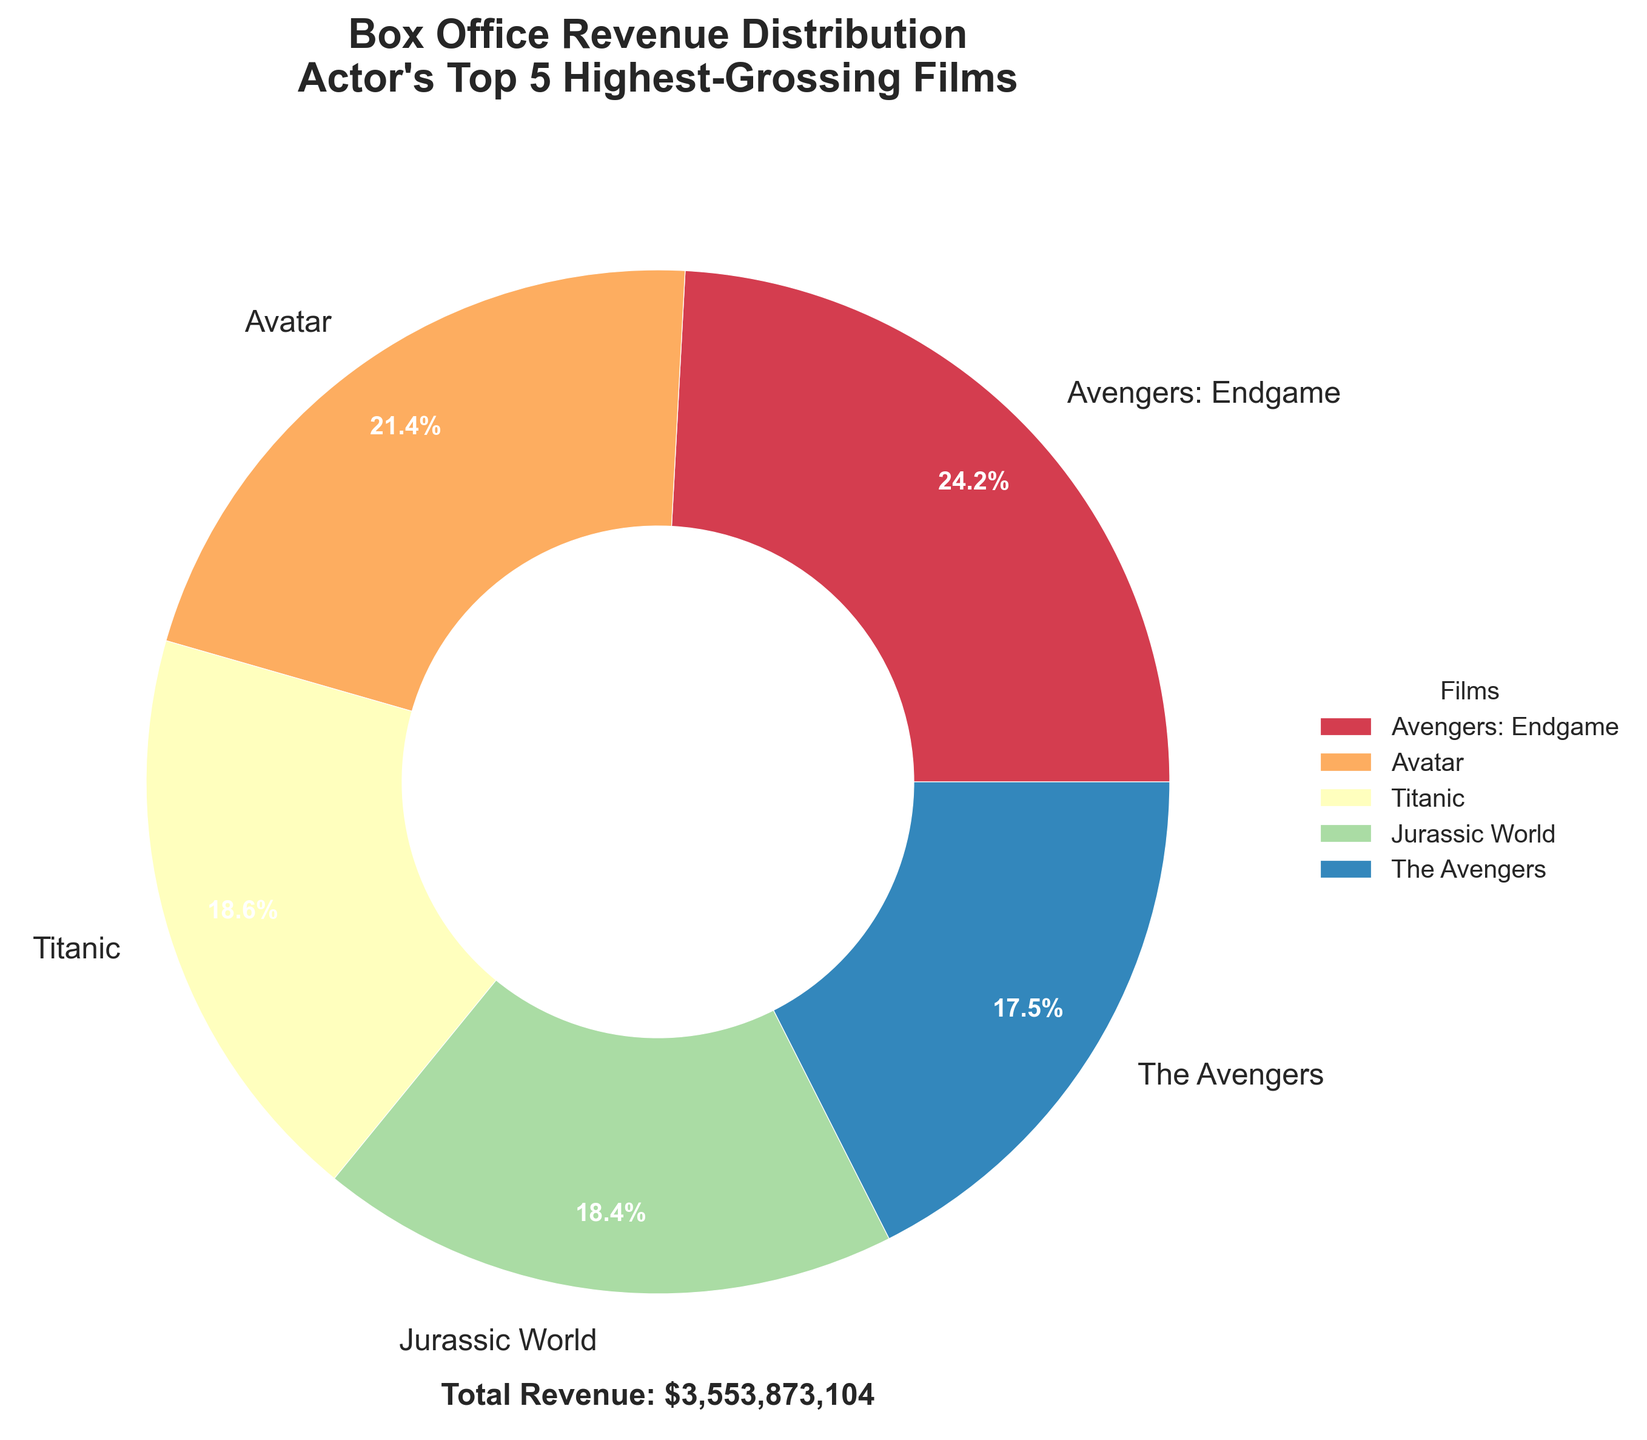What percentage of box office revenue is contributed by 'Avengers: Endgame'? 'Avengers: Endgame' occupies the largest wedge in the pie chart. According to the figure, the pie chart shows the percentage next to each label, and for 'Avengers: Endgame', it's 25.1%.
Answer: 25.1% Which film has the lowest box office revenue in the actor's top 5 highest-grossing films? The pie chart shows the relative sizes of the wedges. The smallest wedge relates to 'The Avengers', and according to the data listed in the chart's labels, 'The Avengers' has the smallest box office revenue.
Answer: The Avengers How much more revenue did 'Avengers: Endgame' generate compared to 'The Avengers'? From the given data, 'Avengers: Endgame' made $858,373,000 while 'The Avengers' made $623,357,910. The difference is $858,373,000 - $623,357,910.
Answer: $235,015,090 If you combine the box office revenues of 'Titanic' and 'Jurassic World', what percentage of the total box office revenue does it represent? The revenues are $659,363,944 for 'Titanic' and $652,270,625 for 'Jurassic World'. Combined, this is $1,311,634,569. The total revenue (sum of all film revenues) is $858,373,000 + $760,507,625 + $659,363,944 + $652,270,625 + $623,357,910 = $3,553,873,104. The percentage is ($1,311,634,569 / $3,553,873,104) * 100.
Answer: 36.9% Which two films together account for more than half of the total box office revenue? The top two highest-grossing films according to the data are 'Avengers: Endgame' and 'Avatar'. Their combined revenue is $858,373,000 + $760,507,625 = $1,618,880,625. The total revenue is $3,553,873,104. The combined percentage is ($1,618,880,625 / $3,553,873,104) * 100 = 45.6%. To find more than half, we need to include 'Titanic'. 'Avengers: Endgame', 'Avatar', and 'Titanic' together make $2,278,244,569 which is 64.1% of the total.
Answer: Avengers: Endgame, Avatar and Titanic What percentage of the total revenue is contributed by the films other than 'Avatar'? 'Avatar' has a revenue of $760,507,625. The total revenue is $3,553,873,104. The revenue from other films is $3,553,873,104 - $760,507,625. The percentage is (($3,553,873,104 - $760,507,625) / $3,553,873,104) * 100.
Answer: 78.6% Which film's wedge is visually closest in size to that of 'Jurassic World'? By visually looking at the pie chart, the wedge sizes of 'Titanic' and 'Jurassic World' appear very close. Comparing the percentages, 'Titanic' and 'Jurassic World' are very close to each other.
Answer: Titanic 